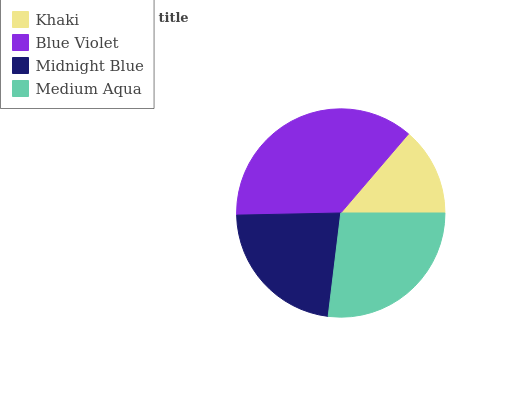Is Khaki the minimum?
Answer yes or no. Yes. Is Blue Violet the maximum?
Answer yes or no. Yes. Is Midnight Blue the minimum?
Answer yes or no. No. Is Midnight Blue the maximum?
Answer yes or no. No. Is Blue Violet greater than Midnight Blue?
Answer yes or no. Yes. Is Midnight Blue less than Blue Violet?
Answer yes or no. Yes. Is Midnight Blue greater than Blue Violet?
Answer yes or no. No. Is Blue Violet less than Midnight Blue?
Answer yes or no. No. Is Medium Aqua the high median?
Answer yes or no. Yes. Is Midnight Blue the low median?
Answer yes or no. Yes. Is Blue Violet the high median?
Answer yes or no. No. Is Blue Violet the low median?
Answer yes or no. No. 